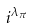<formula> <loc_0><loc_0><loc_500><loc_500>i ^ { \lambda _ { \pi } }</formula> 